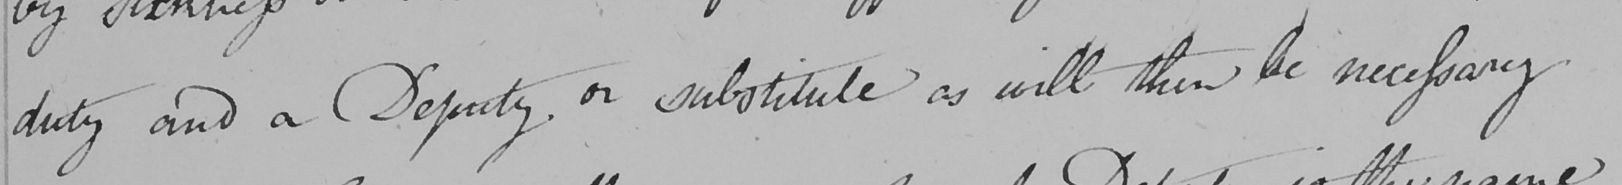Please provide the text content of this handwritten line. duty and a Deputy or other substitute as will then be necessary 